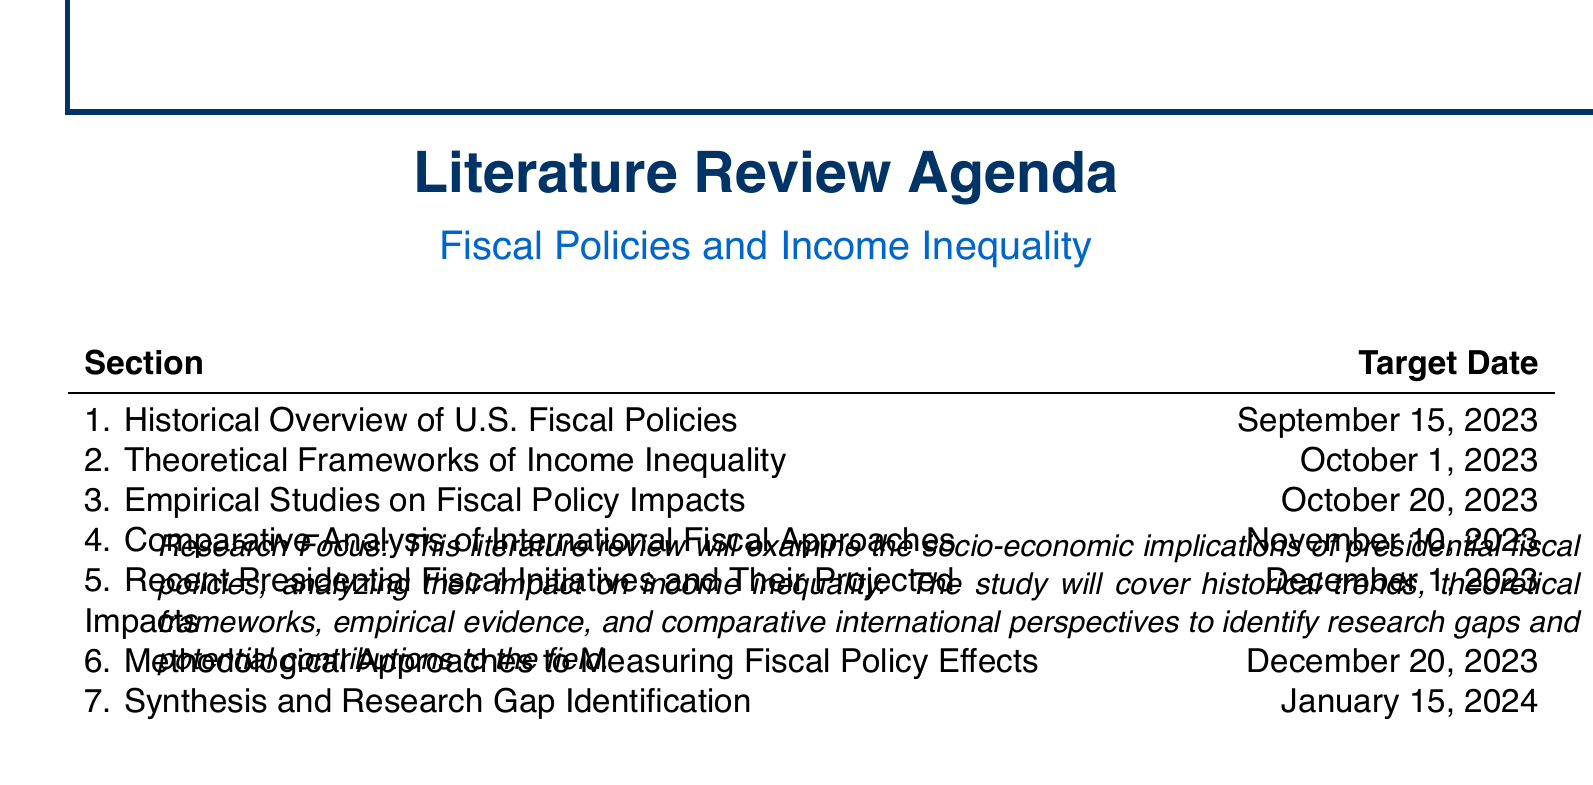What is the title of the dissertation chapter? The title of the dissertation chapter focuses on the socio-economic implications of presidential fiscal policies and their impact on income inequality.
Answer: Fiscal Policies and Income Inequality When is the target completion date for the section on Theoretical Frameworks of Income Inequality? The target completion date for this section helps to establish a timeline for research activities.
Answer: October 1, 2023 Who is one key author referenced in the Historical Overview of U.S. Fiscal Policies section? This question aims to retrieve specific information about authors related to the section.
Answer: Joseph J. Thorndike What key focus area is addressed in the Comparative Analysis of International Fiscal Approaches section? Understanding the focus of this section involves the comparative aspect of fiscal policies between different countries.
Answer: Compare U.S. fiscal policies with those of other OECD countries What is the last section listed in the literature review agenda? This determines the last area that will be covered in the literature review, giving insight into its structure.
Answer: Synthesis and Research Gap Identification Which organization provided working papers cited in the Empirical Studies on Fiscal Policy Impacts section? Knowing the organizations involved helps to assess credibility and relevance of sources used in the literature review.
Answer: National Bureau of Economic Research What type of methodological resources are included in the Methodological Approaches section? This assists in identifying the nature of resources to be reviewed for methodological insights.
Answer: Methodological papers How many sections are there in the literature review agenda? This question looks for a total count, which gives a sense of the scope of the review.
Answer: Seven 